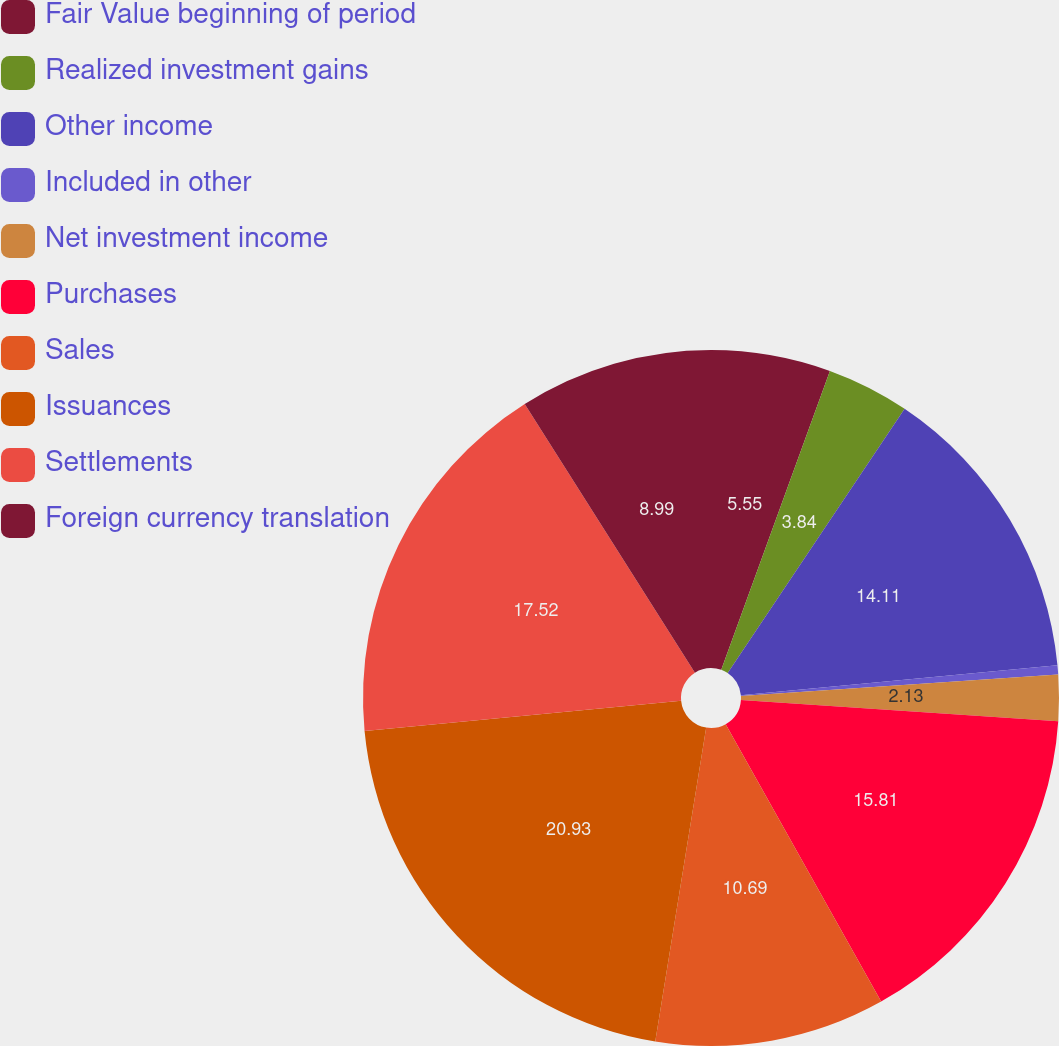Convert chart. <chart><loc_0><loc_0><loc_500><loc_500><pie_chart><fcel>Fair Value beginning of period<fcel>Realized investment gains<fcel>Other income<fcel>Included in other<fcel>Net investment income<fcel>Purchases<fcel>Sales<fcel>Issuances<fcel>Settlements<fcel>Foreign currency translation<nl><fcel>5.55%<fcel>3.84%<fcel>14.11%<fcel>0.43%<fcel>2.13%<fcel>15.81%<fcel>10.69%<fcel>20.93%<fcel>17.52%<fcel>8.99%<nl></chart> 